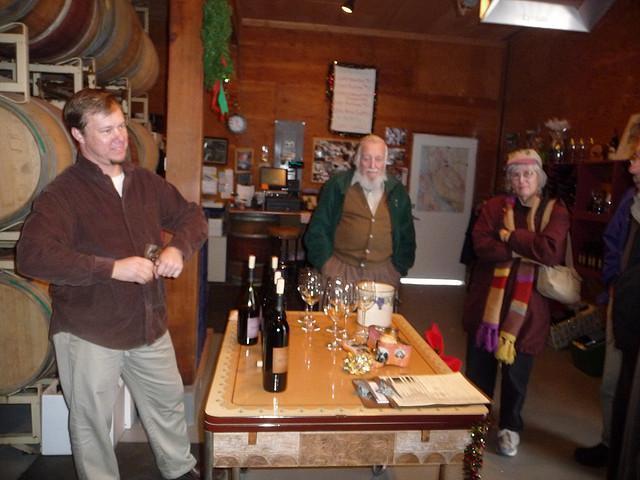How many horseshoes do you see?
Give a very brief answer. 0. How many people can be seen?
Give a very brief answer. 4. 